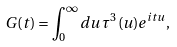<formula> <loc_0><loc_0><loc_500><loc_500>G ( t ) = \int _ { 0 } ^ { \infty } d u \, \tau ^ { 3 } ( u ) e ^ { i t u } ,</formula> 